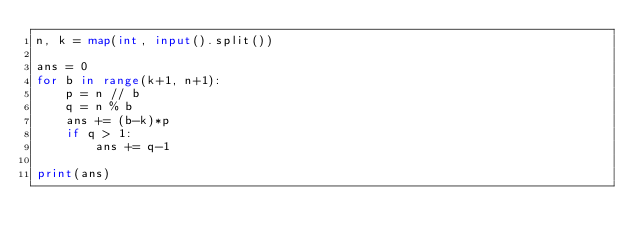<code> <loc_0><loc_0><loc_500><loc_500><_Python_>n, k = map(int, input().split())

ans = 0
for b in range(k+1, n+1):
    p = n // b
    q = n % b
    ans += (b-k)*p
    if q > 1:
        ans += q-1

print(ans)</code> 